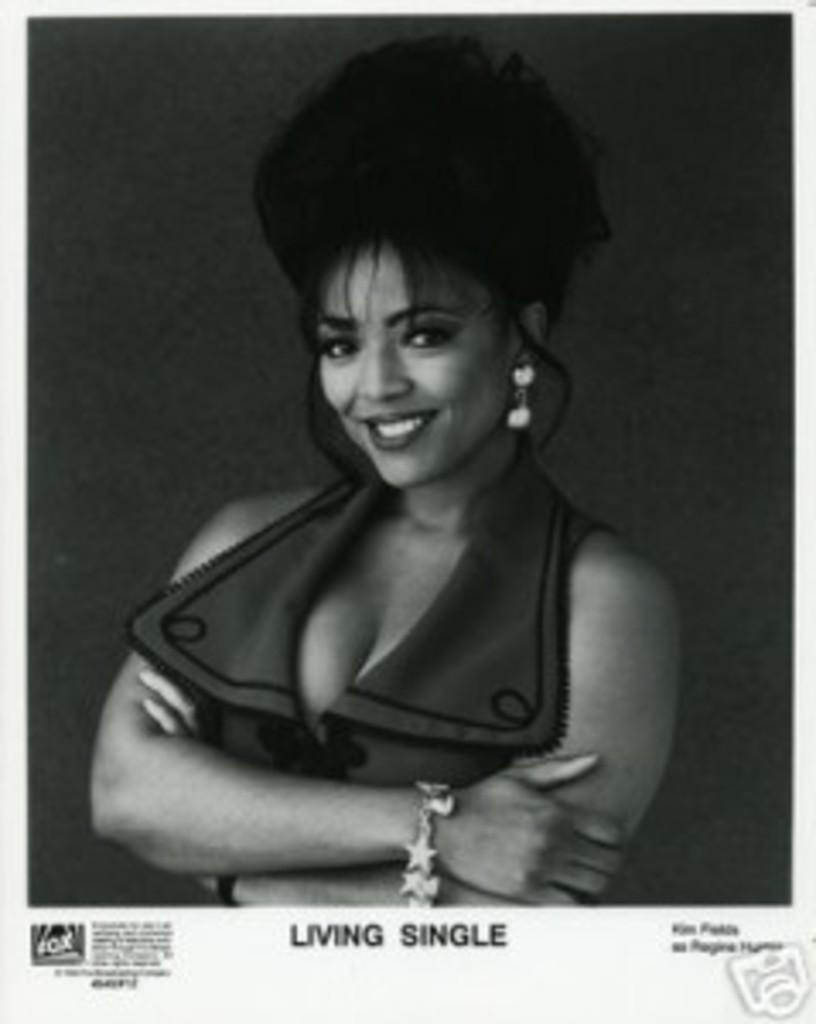What is the main subject of the image? The main subject of the image is a woman. Can you describe any additional elements in the image? Yes, there is some text at the bottom of the image. What type of comb is the woman using on the bear in the image? There is no comb or bear present in the image. How many flowers can be seen in the image? There are no flowers present in the image. 